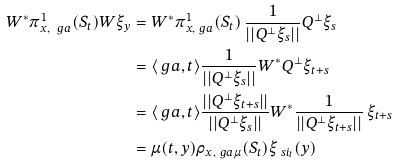<formula> <loc_0><loc_0><loc_500><loc_500>W ^ { * } \pi _ { x , \ g a } ^ { 1 } ( S _ { t } ) W \xi _ { y } & = W ^ { * } \pi _ { x , \ g a } ^ { 1 } ( S _ { t } ) \, \frac { 1 } { | | Q ^ { \perp } \xi _ { s } | | } Q ^ { \perp } \xi _ { s } \\ & = \langle \ g a , t \rangle \frac { 1 } { | | Q ^ { \perp } \xi _ { s } | | } W ^ { * } Q ^ { \perp } \xi _ { t + s } \\ & = \langle \ g a , t \rangle \frac { | | Q ^ { \perp } \xi _ { t + s } | | } { | | Q ^ { \perp } \xi _ { s } | | } W ^ { * } \frac { 1 } { | | Q ^ { \perp } \xi _ { t + s } | | } \, \xi _ { t + s } \\ & = \mu ( t , y ) \rho _ { x , \ g a \mu } ( S _ { t } ) \xi _ { \ s i _ { t } } ( y )</formula> 